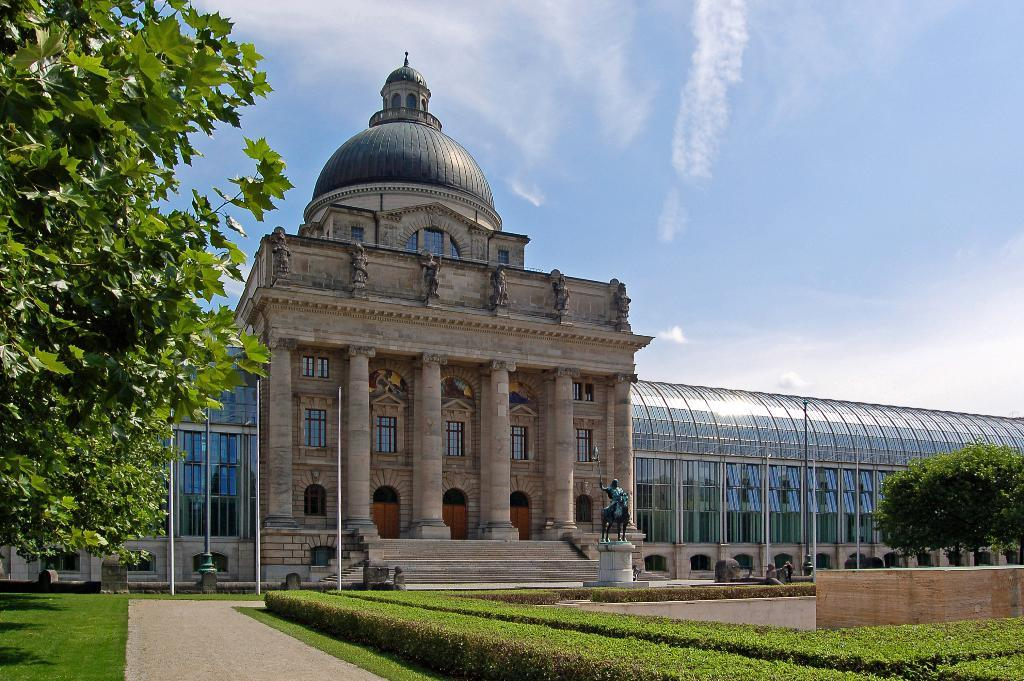What can be seen in the foreground of the image? In the foreground of the image, there is a path, trees, plants, a sculpture, and poles. Can you describe the vegetation in the foreground? The vegetation in the foreground includes trees and plants. What structure is visible in the image? A building is visible in the image. What is visible at the top of the image? The sky is visible at the top of the image. Can you see the moon in the image? The moon is not visible in the image; only the sky is visible at the top. What type of cracker is being used to decorate the sculpture in the image? There is no cracker present in the image, and the sculpture is not being decorated. 